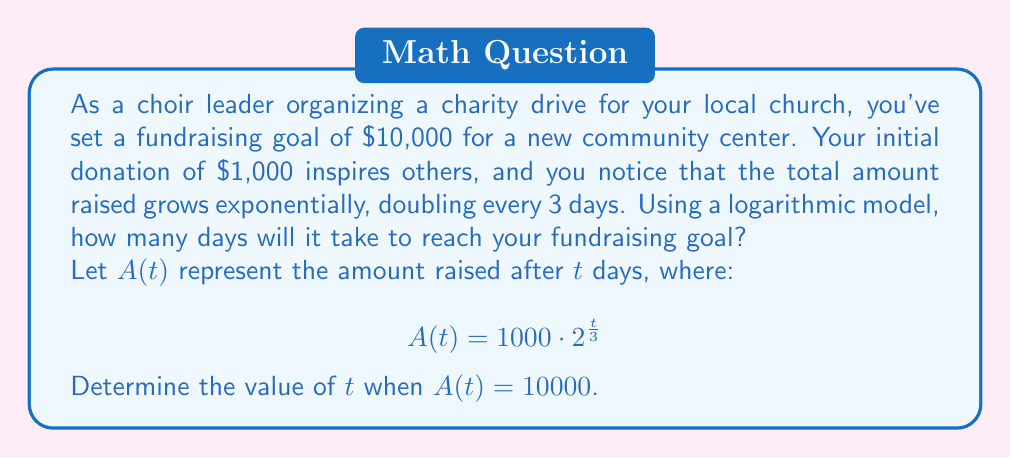Help me with this question. To solve this problem, we'll use the logarithmic model and follow these steps:

1) We start with the equation:
   $$A(t) = 1000 \cdot 2^{\frac{t}{3}}$$

2) We want to find $t$ when $A(t) = 10000$, so we set up the equation:
   $$10000 = 1000 \cdot 2^{\frac{t}{3}}$$

3) Divide both sides by 1000:
   $$10 = 2^{\frac{t}{3}}$$

4) Take the logarithm (base 2) of both sides:
   $$\log_2(10) = \log_2(2^{\frac{t}{3}})$$

5) Using the logarithm property $\log_a(a^x) = x$, we get:
   $$\log_2(10) = \frac{t}{3}$$

6) Multiply both sides by 3:
   $$3\log_2(10) = t$$

7) Calculate the value:
   $$t = 3 \cdot \frac{\ln(10)}{\ln(2)} \approx 9.97$$

8) Since we can't have a fractional day, we round up to the nearest whole day.
Answer: It will take 10 days to reach the fundraising goal of $10,000. 